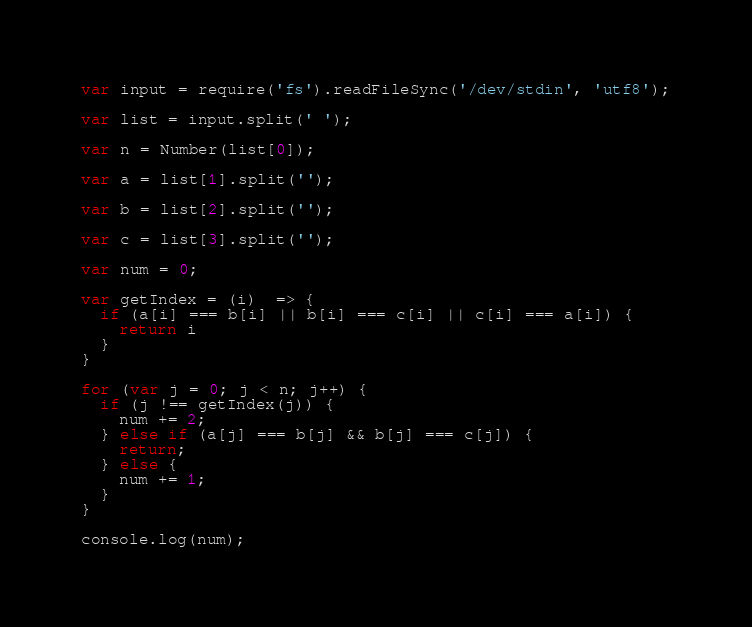Convert code to text. <code><loc_0><loc_0><loc_500><loc_500><_JavaScript_>var input = require('fs').readFileSync('/dev/stdin', 'utf8');

var list = input.split(' ');

var n = Number(list[0]);

var a = list[1].split('');

var b = list[2].split('');

var c = list[3].split('');

var num = 0;

var getIndex = (i)  => {
  if (a[i] === b[i] || b[i] === c[i] || c[i] === a[i]) {
    return i
  }
}

for (var j = 0; j < n; j++) {
  if (j !== getIndex(j)) {
    num += 2;
  } else if (a[j] === b[j] && b[j] === c[j]) {
    return;
  } else {
    num += 1;
  }
}

console.log(num);
</code> 